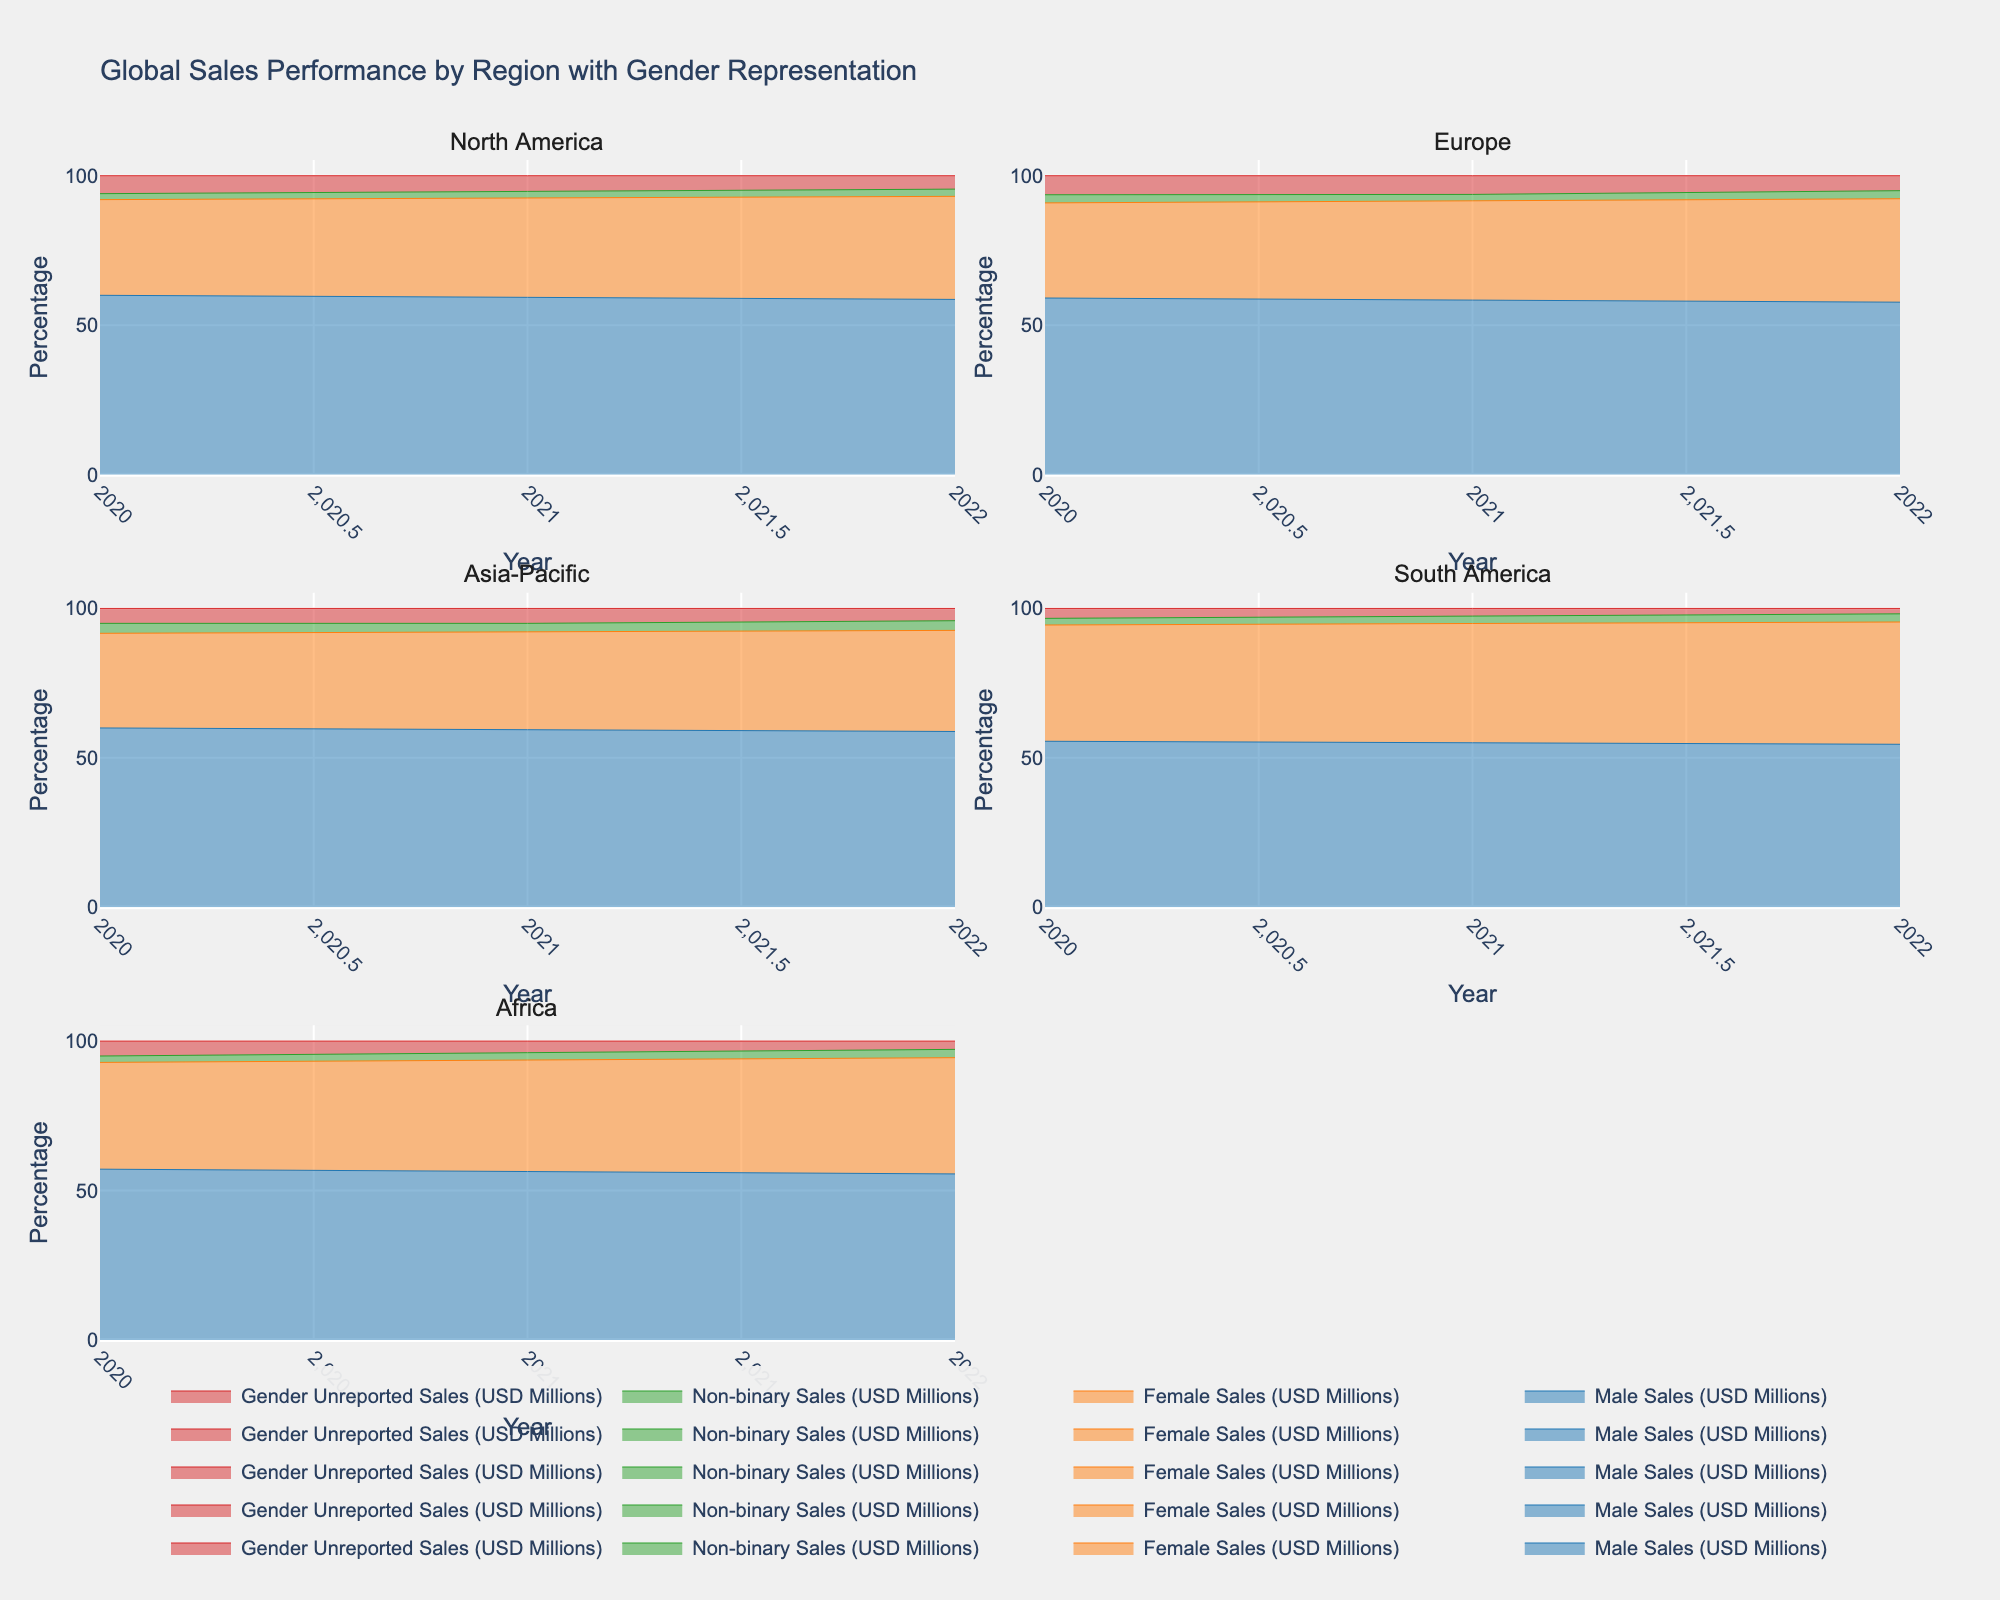Which region had the highest total sales in 2022? By looking at the plot for each region in 2022, we see that the Asia-Pacific region has the highest total sales because its area chart extends the furthest along the vertical axis.
Answer: Asia-Pacific In which region did the percentage of Female Sales show an increasing trend from 2020 to 2022? We need to assess the subplot for each region and observe the pattern for the Female Sales category. Only in Europe, Female Sales show a clear increasing trend over the years.
Answer: Europe How does the proportion of Male Sales compare between North America and South America in 2022? Reviewing the area charts for North America and South America in 2022, North America has a larger proportion of Male Sales compared to South America as indicated by a greater portion of the stacked area.
Answer: North America Which gender representation has the smallest contribution to total sales in the Asia-Pacific region over the years? From the subplot of the Asia-Pacific region, we can observe that Non-binary Sales have a consistently smaller percentage compared to the other categories.
Answer: Non-binary Sales What is the percentage range of Female Sales in Africa from 2020 to 2022? Examining the subplot for Africa, the Female Sales area can be observed to be between 30% and 40% throughout the years.
Answer: 30%-40% How did the sales performance of non-binary gender change in Europe from 2020 to 2022? Looking at the subplot for Europe, the area representing Non-binary Sales remains fairly stable with slight variations, showing a small increase.
Answer: Slight increase Comparing the change in total sales from 2020 to 2021, which region witnessed the largest increase? We need to compare the total height (total sales) difference from 2020 to 2021 across all regions. Asia-Pacific shows the largest increase in sales between these years.
Answer: Asia-Pacific Which region has the most balanced gender representation in terms of sales in 2022? By examining the 2022 section of each subplot, Africa’s proportions of Male and Female Sales appear the most balanced compared to other regions.
Answer: Africa Is there a region in which Male Sales decreased over the years 2020 to 2022? The Male Sales portion of the area graph did not decrease in any of the regions over these years. Each showed either an increase or remained stable.
Answer: No What trend can be observed in Gender Unreported Sales in South America from 2020 to 2022? Review the South America subplot to see that the portion of Gender Unreported Sales decreases from 2020 to 2022.
Answer: Decreasing 